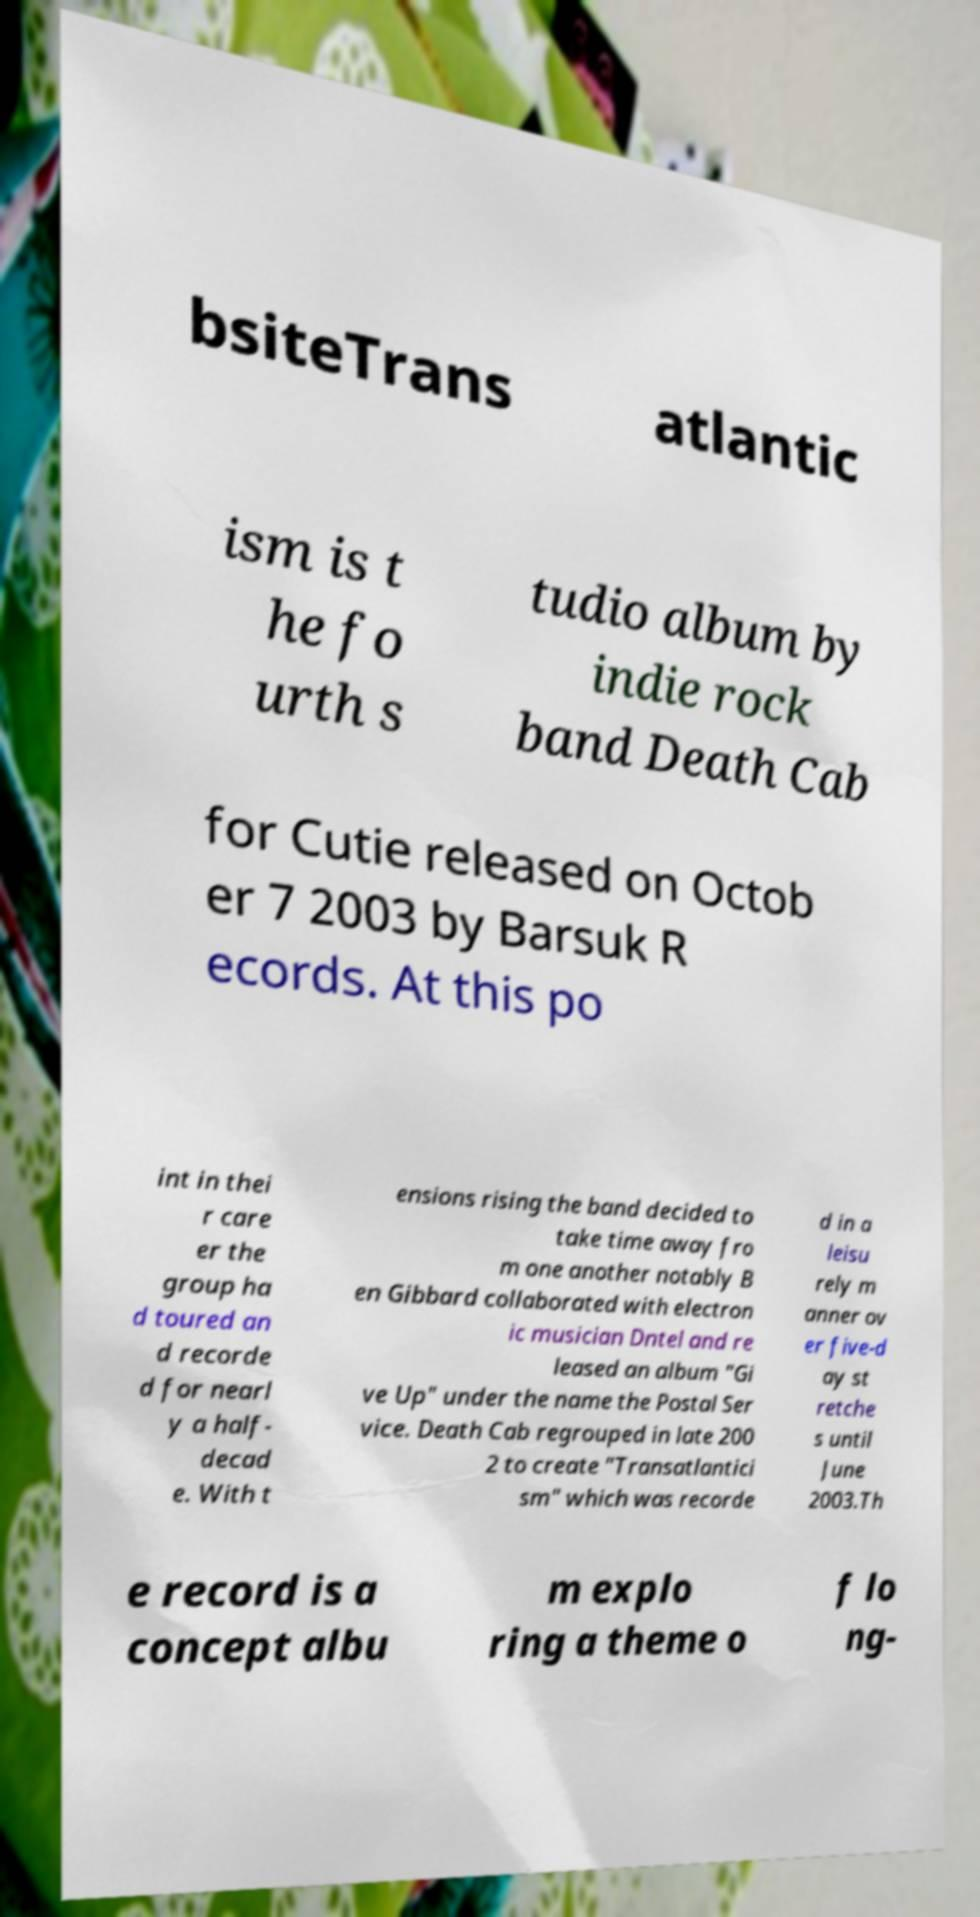For documentation purposes, I need the text within this image transcribed. Could you provide that? bsiteTrans atlantic ism is t he fo urth s tudio album by indie rock band Death Cab for Cutie released on Octob er 7 2003 by Barsuk R ecords. At this po int in thei r care er the group ha d toured an d recorde d for nearl y a half- decad e. With t ensions rising the band decided to take time away fro m one another notably B en Gibbard collaborated with electron ic musician Dntel and re leased an album "Gi ve Up" under the name the Postal Ser vice. Death Cab regrouped in late 200 2 to create "Transatlantici sm" which was recorde d in a leisu rely m anner ov er five-d ay st retche s until June 2003.Th e record is a concept albu m explo ring a theme o f lo ng- 